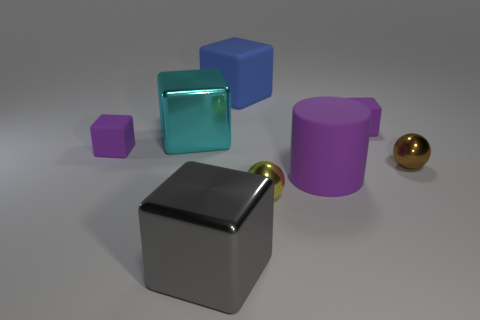Can you describe the objects on the left side of the image? On the left side of the image, there is a large matte grey cube and a smaller, similarly colored cube with a metallic texture. Positioned between them is a transparent green cube with a glass-like appearance. 